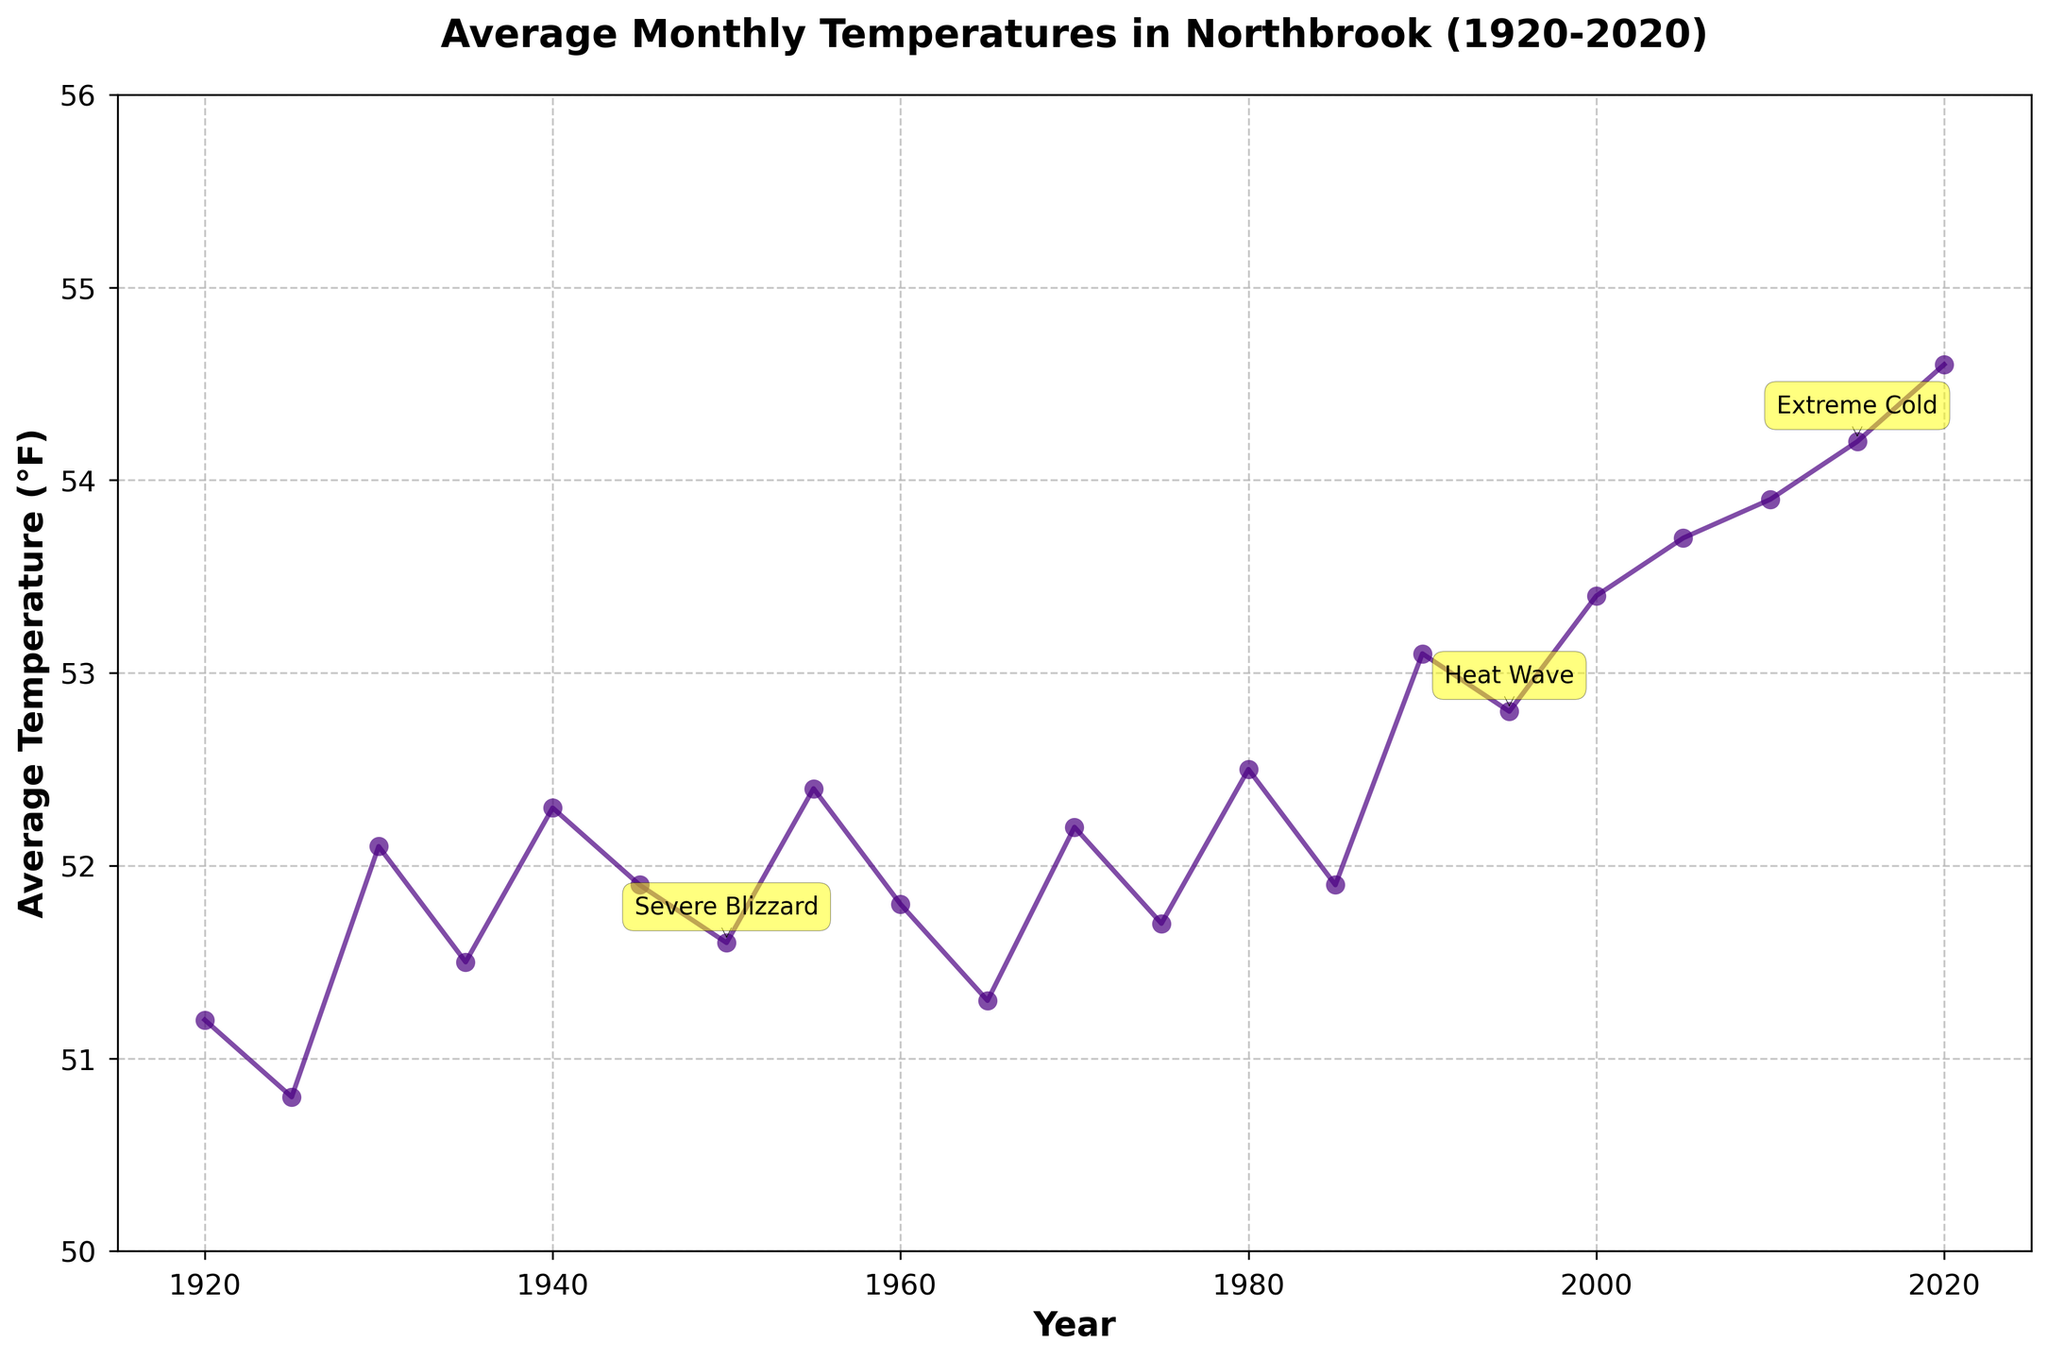How has the average temperature trend changed over the century? To identify the temperature trend, observe the overall pattern of the line in the plot. There is a visible upward trend in the average temperatures from 1920 to 2020, indicating a general increase over the century.
Answer: Increasing Which extreme weather event led to a noticeable drop in average temperature around the mid-century? Find the year with a tagged extreme event and a visible drop in temperature. In the data, "Severe Blizzard" in 1950 corresponds with a noticeable drop in average temperature.
Answer: Severe Blizzard What is the temperature difference between the highest and lowest recorded average temperatures? Identify the highest and lowest points on the graph. The highest is around 2020 at 54.6°F, and the lowest is around 1925 at 50.8°F. Calculate the difference: 54.6 - 50.8 = 3.8°F.
Answer: 3.8°F How did the average temperature change after the 1995 heat wave? Observe the temperature levels before and after 1995. The temperature continued to increase, rising from around 52.8°F in 1995 to approximately 54.6°F in 2020.
Answer: Increased What color is used to represent the temperature line in the plot? Look for the visual attribute of the plotted line. It is colored in a shade of indigo or dark purple.
Answer: Indigo Which year had the lowest average temperature, and what notable event happened close to this date? Identify the year with the lowest temperature. It's 1925 with an average temperature of 50.8°F. There were no extreme events tagged around this year.
Answer: 1925; None Compare the average temperature differences before and after the Severe Blizzard in 1950. Identify the temperature in 1950, the year of the Severe Blizzard, and compare it to the years before (1945) and after (1955). In 1945, it was 51.9°F; in 1950, it was 51.6°F; and in 1955, it was 52.4°F. Calculate differences: 51.6 - 51.9 = -0.3°F (before) and 52.4 - 51.6 = 0.8°F (after).
Answer: Before: -0.3°F; After: 0.8°F What were the average temperatures during the years with extreme weather events? Examine the plot for years tagged with extreme weather and note the corresponding temperatures. For example, 1950 (Severe Blizzard) had 51.6°F, 1995 (Heat Wave) had 52.8°F, and 2015 (Extreme Cold) had 54.2°F.
Answer: 51.6°F, 52.8°F, 54.2°F Which decade experienced the highest increase in average temperature? Compare each decade's starting and ending temperatures to find the highest increase. The decade from 2010 to 2020 shows an increase from 53.9°F to 54.6°F (54.6 - 53.9 = 0.7°F).
Answer: 2010s 